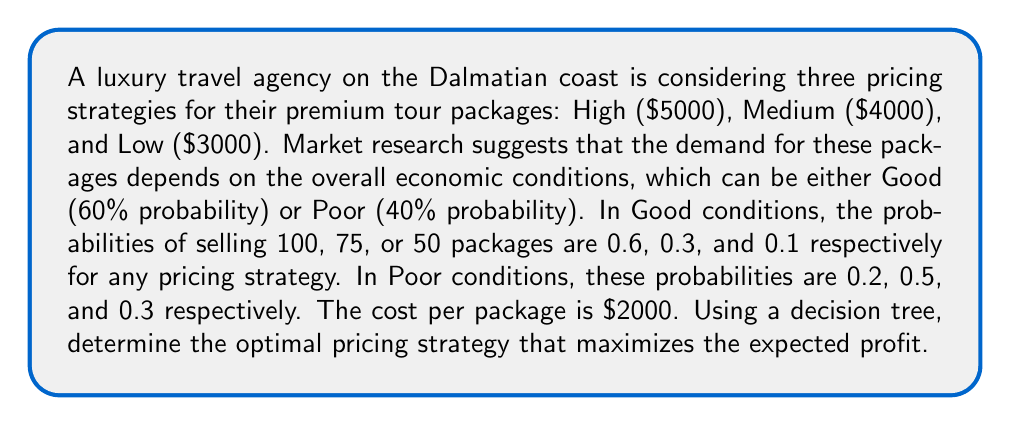Could you help me with this problem? Let's approach this problem step-by-step using a decision tree:

1) First, we need to calculate the profit for each combination of pricing strategy and number of packages sold:

   High pricing ($5000):
   - 100 packages: $$ 100 \times (5000 - 2000) = 300,000 $$
   - 75 packages: $$ 75 \times (5000 - 2000) = 225,000 $$
   - 50 packages: $$ 50 \times (5000 - 2000) = 150,000 $$

   Medium pricing ($4000):
   - 100 packages: $$ 100 \times (4000 - 2000) = 200,000 $$
   - 75 packages: $$ 75 \times (4000 - 2000) = 150,000 $$
   - 50 packages: $$ 50 \times (4000 - 2000) = 100,000 $$

   Low pricing ($3000):
   - 100 packages: $$ 100 \times (3000 - 2000) = 100,000 $$
   - 75 packages: $$ 75 \times (3000 - 2000) = 75,000 $$
   - 50 packages: $$ 50 \times (3000 - 2000) = 50,000 $$

2) Now, let's calculate the expected profit for each pricing strategy in Good and Poor conditions:

   High pricing:
   Good: $$ 0.6 \times 300,000 + 0.3 \times 225,000 + 0.1 \times 150,000 = 255,000 $$
   Poor: $$ 0.2 \times 300,000 + 0.5 \times 225,000 + 0.3 \times 150,000 = 217,500 $$

   Medium pricing:
   Good: $$ 0.6 \times 200,000 + 0.3 \times 150,000 + 0.1 \times 100,000 = 170,000 $$
   Poor: $$ 0.2 \times 200,000 + 0.5 \times 150,000 + 0.3 \times 100,000 = 145,000 $$

   Low pricing:
   Good: $$ 0.6 \times 100,000 + 0.3 \times 75,000 + 0.1 \times 50,000 = 85,000 $$
   Poor: $$ 0.2 \times 100,000 + 0.5 \times 75,000 + 0.3 \times 50,000 = 72,500 $$

3) Finally, we calculate the overall expected profit for each pricing strategy:

   High: $$ 0.6 \times 255,000 + 0.4 \times 217,500 = 240,000 $$
   Medium: $$ 0.6 \times 170,000 + 0.4 \times 145,000 = 160,000 $$
   Low: $$ 0.6 \times 85,000 + 0.4 \times 72,500 = 80,000 $$

The decision tree would look like this:

[asy]
import geometry;

pair root = (0,0);
pair h = (2,1);
pair m = (2,0);
pair l = (2,-1);

draw(root--h, arrow=Arrow(TeXHead));
draw(root--m, arrow=Arrow(TeXHead));
draw(root--l, arrow=Arrow(TeXHead));

label("High", (1,0.5), N);
label("Medium", (1,0), N);
label("Low", (1,-0.5), N);

label("$240,000", (2.5,1), E);
label("$160,000", (2.5,0), E);
label("$80,000", (2.5,-1), E);

dot(root);
dot(h);
dot(m);
dot(l);

label("Decision", (-0.5,0), W);
[/asy]
Answer: The optimal pricing strategy is High ($5000 per package), which yields an expected profit of $240,000. 